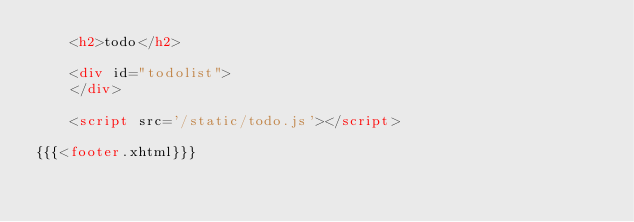<code> <loc_0><loc_0><loc_500><loc_500><_HTML_>	<h2>todo</h2>
	
	<div id="todolist">
	</div>
		
	<script src='/static/todo.js'></script>

{{{<footer.xhtml}}}
</code> 